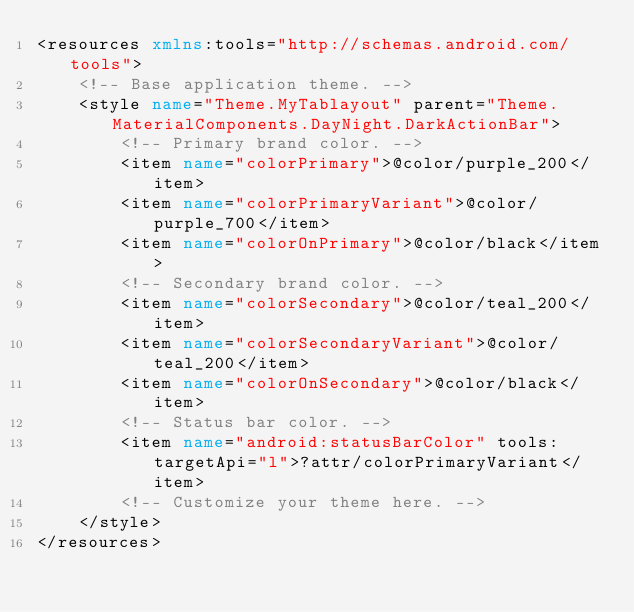<code> <loc_0><loc_0><loc_500><loc_500><_XML_><resources xmlns:tools="http://schemas.android.com/tools">
    <!-- Base application theme. -->
    <style name="Theme.MyTablayout" parent="Theme.MaterialComponents.DayNight.DarkActionBar">
        <!-- Primary brand color. -->
        <item name="colorPrimary">@color/purple_200</item>
        <item name="colorPrimaryVariant">@color/purple_700</item>
        <item name="colorOnPrimary">@color/black</item>
        <!-- Secondary brand color. -->
        <item name="colorSecondary">@color/teal_200</item>
        <item name="colorSecondaryVariant">@color/teal_200</item>
        <item name="colorOnSecondary">@color/black</item>
        <!-- Status bar color. -->
        <item name="android:statusBarColor" tools:targetApi="l">?attr/colorPrimaryVariant</item>
        <!-- Customize your theme here. -->
    </style>
</resources></code> 